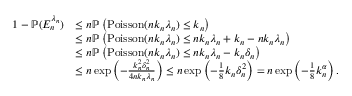<formula> <loc_0><loc_0><loc_500><loc_500>\begin{array} { r l } { 1 - \mathbb { P } ( E _ { n } ^ { \lambda _ { n } } ) } & { \leq n \mathbb { P } \left ( P o i s s o n ( n k _ { n } \lambda _ { n } ) \leq k _ { n } \right ) } \\ & { \leq n \mathbb { P } \left ( P o i s s o n ( n k _ { n } \lambda _ { n } ) \leq n k _ { n } \lambda _ { n } + k _ { n } - n k _ { n } \lambda _ { n } \right ) } \\ & { \leq n \mathbb { P } \left ( P o i s s o n ( n k _ { n } \lambda _ { n } ) \leq n k _ { n } \lambda _ { n } - k _ { n } \delta _ { n } \right ) } \\ & { \leq n \exp \left ( - \frac { k _ { n } ^ { 2 } \delta _ { n } ^ { 2 } } { 4 n k _ { n } \lambda _ { n } } \right ) \leq n \exp \left ( - \frac { 1 } { 8 } k _ { n } \delta _ { n } ^ { 2 } \right ) = n \exp \left ( - \frac { 1 } { 8 } k _ { n } ^ { \alpha } \right ) . } \end{array}</formula> 